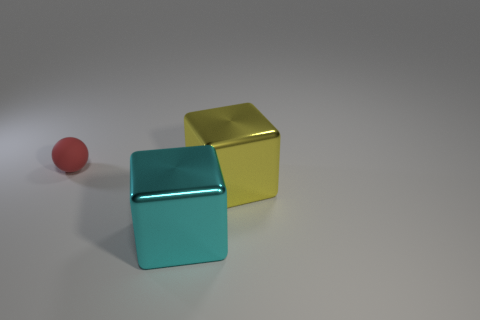There is a red ball; is it the same size as the metal block in front of the yellow metallic thing?
Offer a very short reply. No. How many other things are made of the same material as the small red sphere?
Keep it short and to the point. 0. Is there anything else that has the same shape as the cyan shiny object?
Offer a very short reply. Yes. The object that is right of the cube in front of the big shiny cube right of the large cyan thing is what color?
Ensure brevity in your answer.  Yellow. There is a thing that is both left of the big yellow thing and behind the cyan object; what shape is it?
Make the answer very short. Sphere. Is there anything else that is the same size as the yellow metal thing?
Your response must be concise. Yes. There is a large shiny thing that is on the right side of the big metallic cube to the left of the yellow object; what is its color?
Your answer should be compact. Yellow. There is a metal thing that is behind the big metal thing that is in front of the metal cube to the right of the big cyan object; what is its shape?
Your response must be concise. Cube. How big is the thing that is to the left of the yellow block and in front of the tiny red matte object?
Your answer should be compact. Large. How many objects are the same color as the sphere?
Offer a very short reply. 0. 